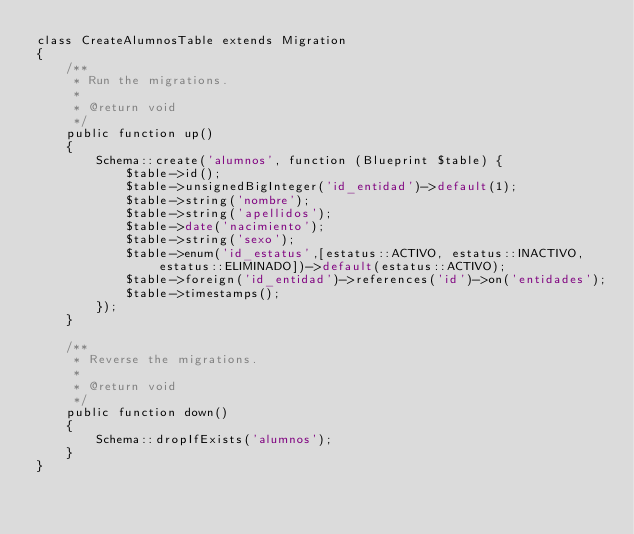<code> <loc_0><loc_0><loc_500><loc_500><_PHP_>class CreateAlumnosTable extends Migration
{
    /**
     * Run the migrations.
     *
     * @return void
     */
    public function up()
    {
        Schema::create('alumnos', function (Blueprint $table) {
            $table->id();
            $table->unsignedBigInteger('id_entidad')->default(1);
            $table->string('nombre');
            $table->string('apellidos');
            $table->date('nacimiento');
            $table->string('sexo');
            $table->enum('id_estatus',[estatus::ACTIVO, estatus::INACTIVO, estatus::ELIMINADO])->default(estatus::ACTIVO);
            $table->foreign('id_entidad')->references('id')->on('entidades');
            $table->timestamps();
        });
    }

    /**
     * Reverse the migrations.
     *
     * @return void
     */
    public function down()
    {
        Schema::dropIfExists('alumnos');
    }
}
</code> 